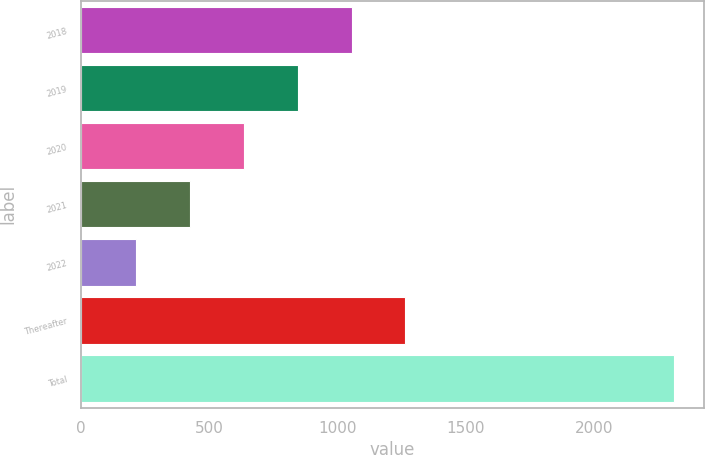<chart> <loc_0><loc_0><loc_500><loc_500><bar_chart><fcel>2018<fcel>2019<fcel>2020<fcel>2021<fcel>2022<fcel>Thereafter<fcel>Total<nl><fcel>1053.8<fcel>844.1<fcel>634.4<fcel>424.7<fcel>215<fcel>1263.5<fcel>2312<nl></chart> 